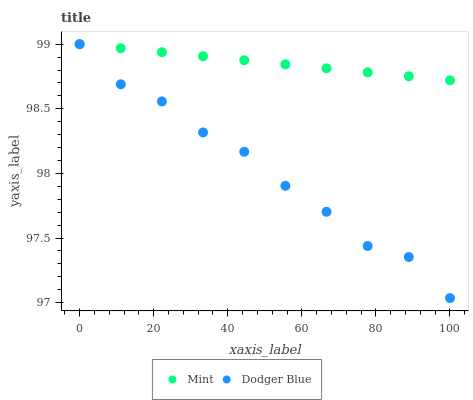Does Dodger Blue have the minimum area under the curve?
Answer yes or no. Yes. Does Mint have the maximum area under the curve?
Answer yes or no. Yes. Does Mint have the minimum area under the curve?
Answer yes or no. No. Is Mint the smoothest?
Answer yes or no. Yes. Is Dodger Blue the roughest?
Answer yes or no. Yes. Is Mint the roughest?
Answer yes or no. No. Does Dodger Blue have the lowest value?
Answer yes or no. Yes. Does Mint have the lowest value?
Answer yes or no. No. Does Mint have the highest value?
Answer yes or no. Yes. Does Mint intersect Dodger Blue?
Answer yes or no. Yes. Is Mint less than Dodger Blue?
Answer yes or no. No. Is Mint greater than Dodger Blue?
Answer yes or no. No. 